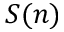<formula> <loc_0><loc_0><loc_500><loc_500>S ( n )</formula> 